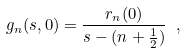<formula> <loc_0><loc_0><loc_500><loc_500>g _ { n } ( s , 0 ) = \frac { r _ { n } ( 0 ) } { s - ( n + \frac { 1 } { 2 } ) } \ ,</formula> 